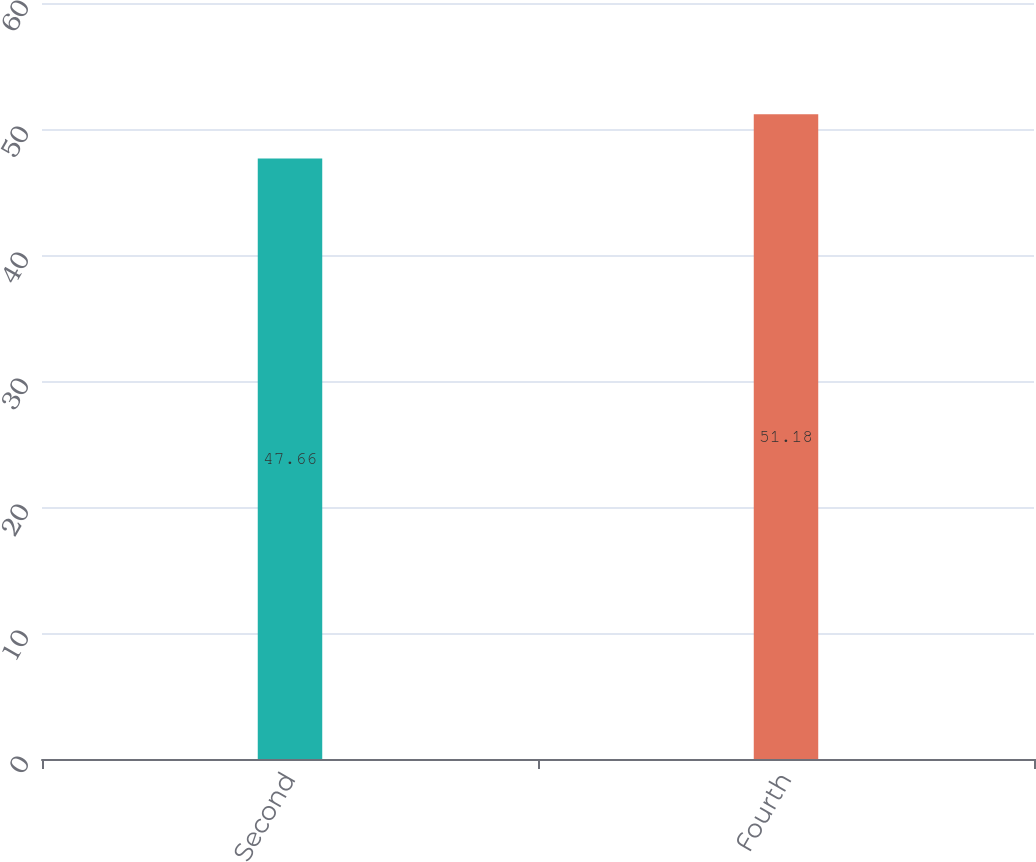Convert chart to OTSL. <chart><loc_0><loc_0><loc_500><loc_500><bar_chart><fcel>Second<fcel>Fourth<nl><fcel>47.66<fcel>51.18<nl></chart> 